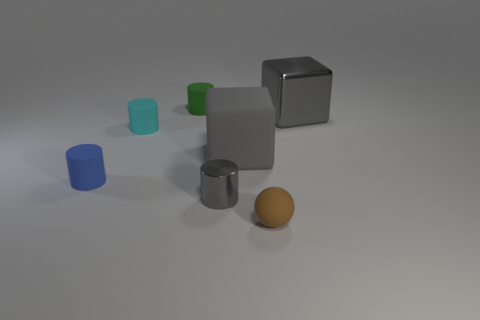Considering the positions of the objects, what could you infer about the spatial arrangement? The objects are arranged with a sense of depth, with some objects closer to the viewpoint and others further away. The spatial arrangement might indicate an intentional placement to demonstrate perspective and scale, with the various sizes and distances of objects relative to each other creating a three-dimensional effect on the two-dimensional surface of the image. 